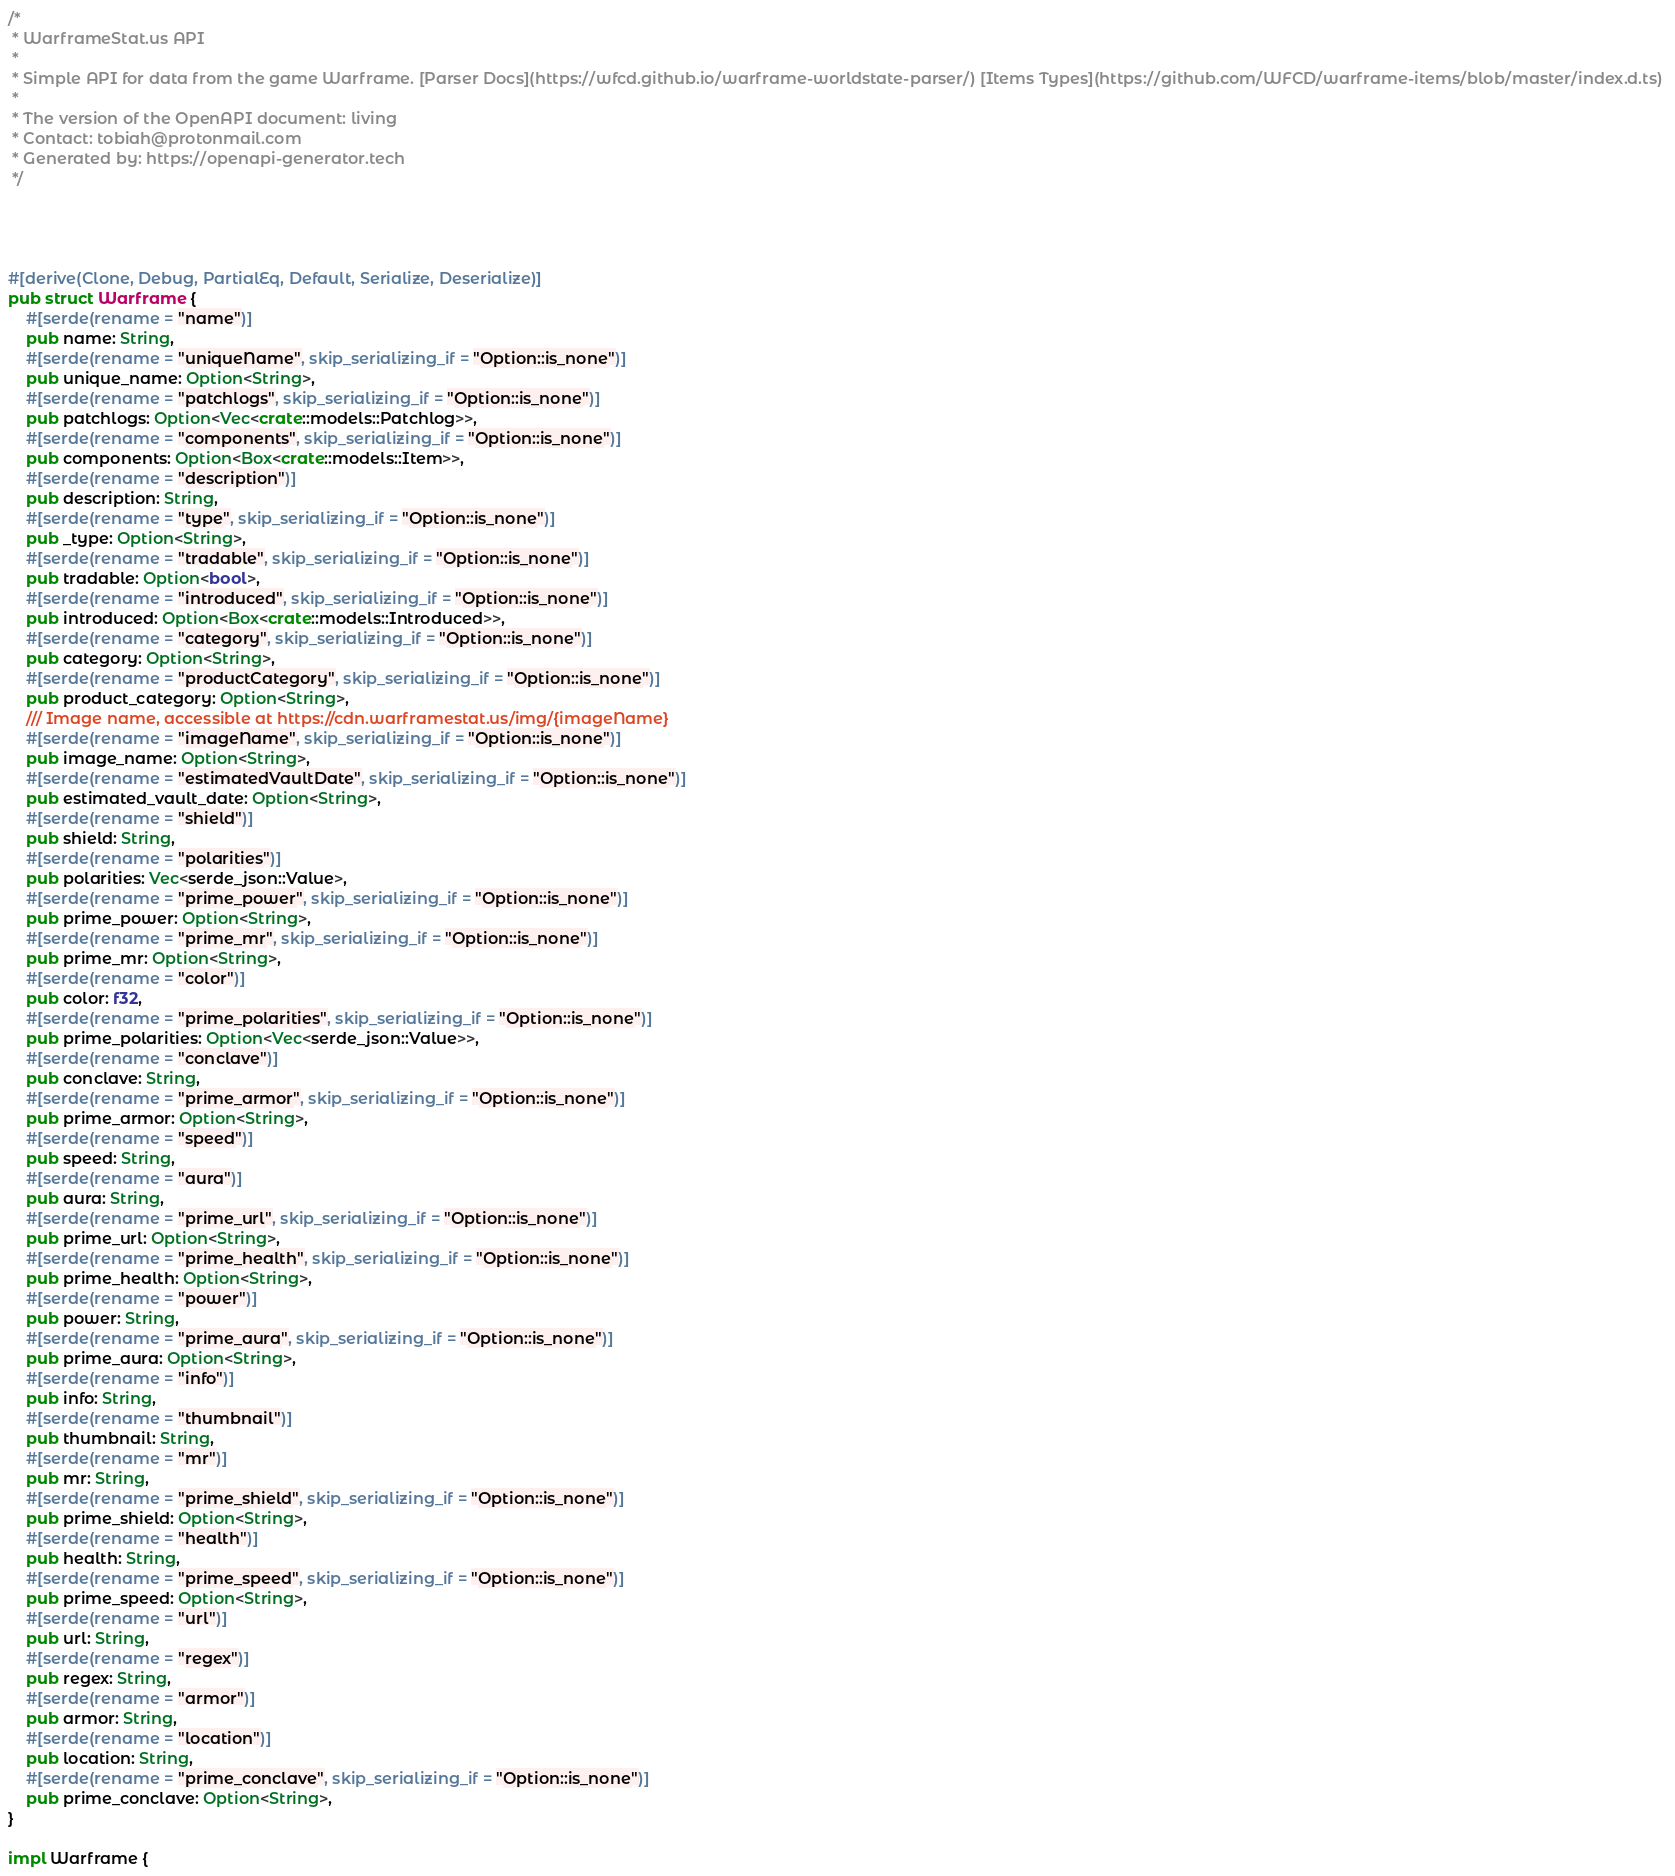<code> <loc_0><loc_0><loc_500><loc_500><_Rust_>/*
 * WarframeStat.us API
 *
 * Simple API for data from the game Warframe. [Parser Docs](https://wfcd.github.io/warframe-worldstate-parser/) [Items Types](https://github.com/WFCD/warframe-items/blob/master/index.d.ts) 
 *
 * The version of the OpenAPI document: living
 * Contact: tobiah@protonmail.com
 * Generated by: https://openapi-generator.tech
 */




#[derive(Clone, Debug, PartialEq, Default, Serialize, Deserialize)]
pub struct Warframe {
    #[serde(rename = "name")]
    pub name: String,
    #[serde(rename = "uniqueName", skip_serializing_if = "Option::is_none")]
    pub unique_name: Option<String>,
    #[serde(rename = "patchlogs", skip_serializing_if = "Option::is_none")]
    pub patchlogs: Option<Vec<crate::models::Patchlog>>,
    #[serde(rename = "components", skip_serializing_if = "Option::is_none")]
    pub components: Option<Box<crate::models::Item>>,
    #[serde(rename = "description")]
    pub description: String,
    #[serde(rename = "type", skip_serializing_if = "Option::is_none")]
    pub _type: Option<String>,
    #[serde(rename = "tradable", skip_serializing_if = "Option::is_none")]
    pub tradable: Option<bool>,
    #[serde(rename = "introduced", skip_serializing_if = "Option::is_none")]
    pub introduced: Option<Box<crate::models::Introduced>>,
    #[serde(rename = "category", skip_serializing_if = "Option::is_none")]
    pub category: Option<String>,
    #[serde(rename = "productCategory", skip_serializing_if = "Option::is_none")]
    pub product_category: Option<String>,
    /// Image name, accessible at https://cdn.warframestat.us/img/{imageName} 
    #[serde(rename = "imageName", skip_serializing_if = "Option::is_none")]
    pub image_name: Option<String>,
    #[serde(rename = "estimatedVaultDate", skip_serializing_if = "Option::is_none")]
    pub estimated_vault_date: Option<String>,
    #[serde(rename = "shield")]
    pub shield: String,
    #[serde(rename = "polarities")]
    pub polarities: Vec<serde_json::Value>,
    #[serde(rename = "prime_power", skip_serializing_if = "Option::is_none")]
    pub prime_power: Option<String>,
    #[serde(rename = "prime_mr", skip_serializing_if = "Option::is_none")]
    pub prime_mr: Option<String>,
    #[serde(rename = "color")]
    pub color: f32,
    #[serde(rename = "prime_polarities", skip_serializing_if = "Option::is_none")]
    pub prime_polarities: Option<Vec<serde_json::Value>>,
    #[serde(rename = "conclave")]
    pub conclave: String,
    #[serde(rename = "prime_armor", skip_serializing_if = "Option::is_none")]
    pub prime_armor: Option<String>,
    #[serde(rename = "speed")]
    pub speed: String,
    #[serde(rename = "aura")]
    pub aura: String,
    #[serde(rename = "prime_url", skip_serializing_if = "Option::is_none")]
    pub prime_url: Option<String>,
    #[serde(rename = "prime_health", skip_serializing_if = "Option::is_none")]
    pub prime_health: Option<String>,
    #[serde(rename = "power")]
    pub power: String,
    #[serde(rename = "prime_aura", skip_serializing_if = "Option::is_none")]
    pub prime_aura: Option<String>,
    #[serde(rename = "info")]
    pub info: String,
    #[serde(rename = "thumbnail")]
    pub thumbnail: String,
    #[serde(rename = "mr")]
    pub mr: String,
    #[serde(rename = "prime_shield", skip_serializing_if = "Option::is_none")]
    pub prime_shield: Option<String>,
    #[serde(rename = "health")]
    pub health: String,
    #[serde(rename = "prime_speed", skip_serializing_if = "Option::is_none")]
    pub prime_speed: Option<String>,
    #[serde(rename = "url")]
    pub url: String,
    #[serde(rename = "regex")]
    pub regex: String,
    #[serde(rename = "armor")]
    pub armor: String,
    #[serde(rename = "location")]
    pub location: String,
    #[serde(rename = "prime_conclave", skip_serializing_if = "Option::is_none")]
    pub prime_conclave: Option<String>,
}

impl Warframe {</code> 